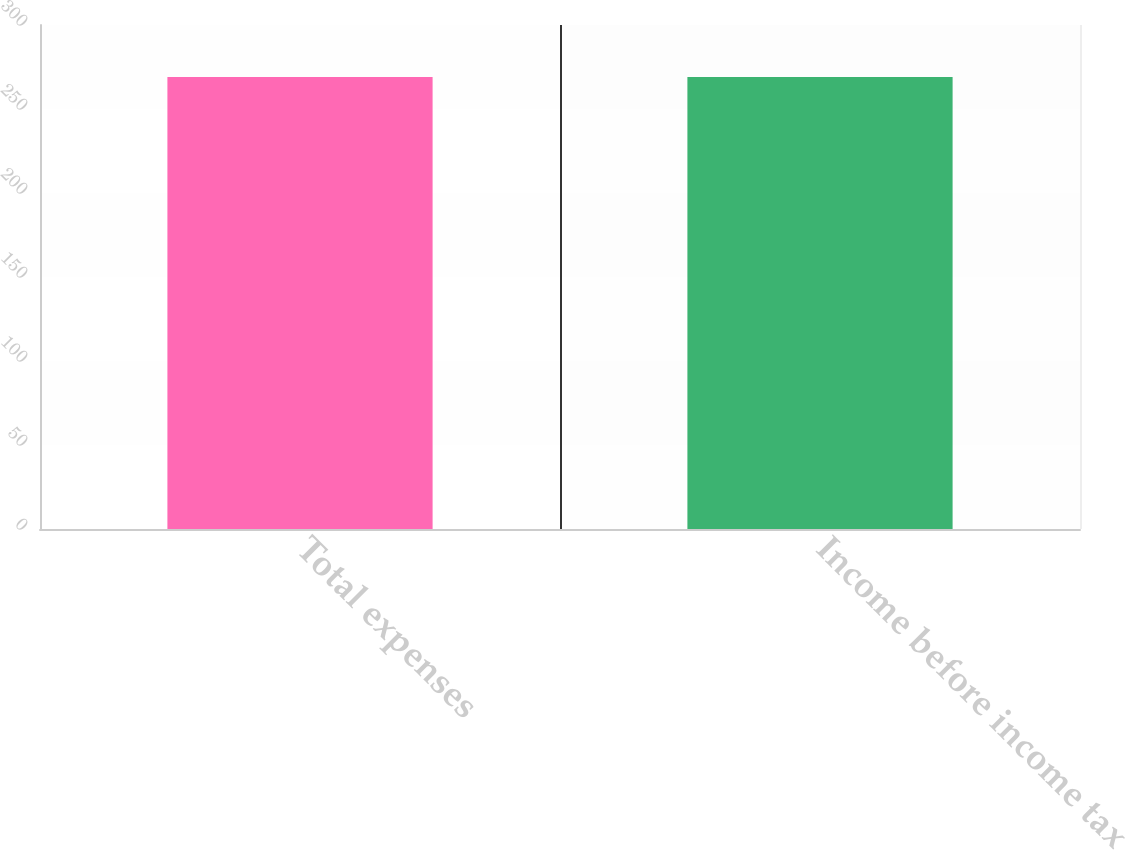<chart> <loc_0><loc_0><loc_500><loc_500><bar_chart><fcel>Total expenses<fcel>Income before income tax<nl><fcel>269<fcel>269.1<nl></chart> 